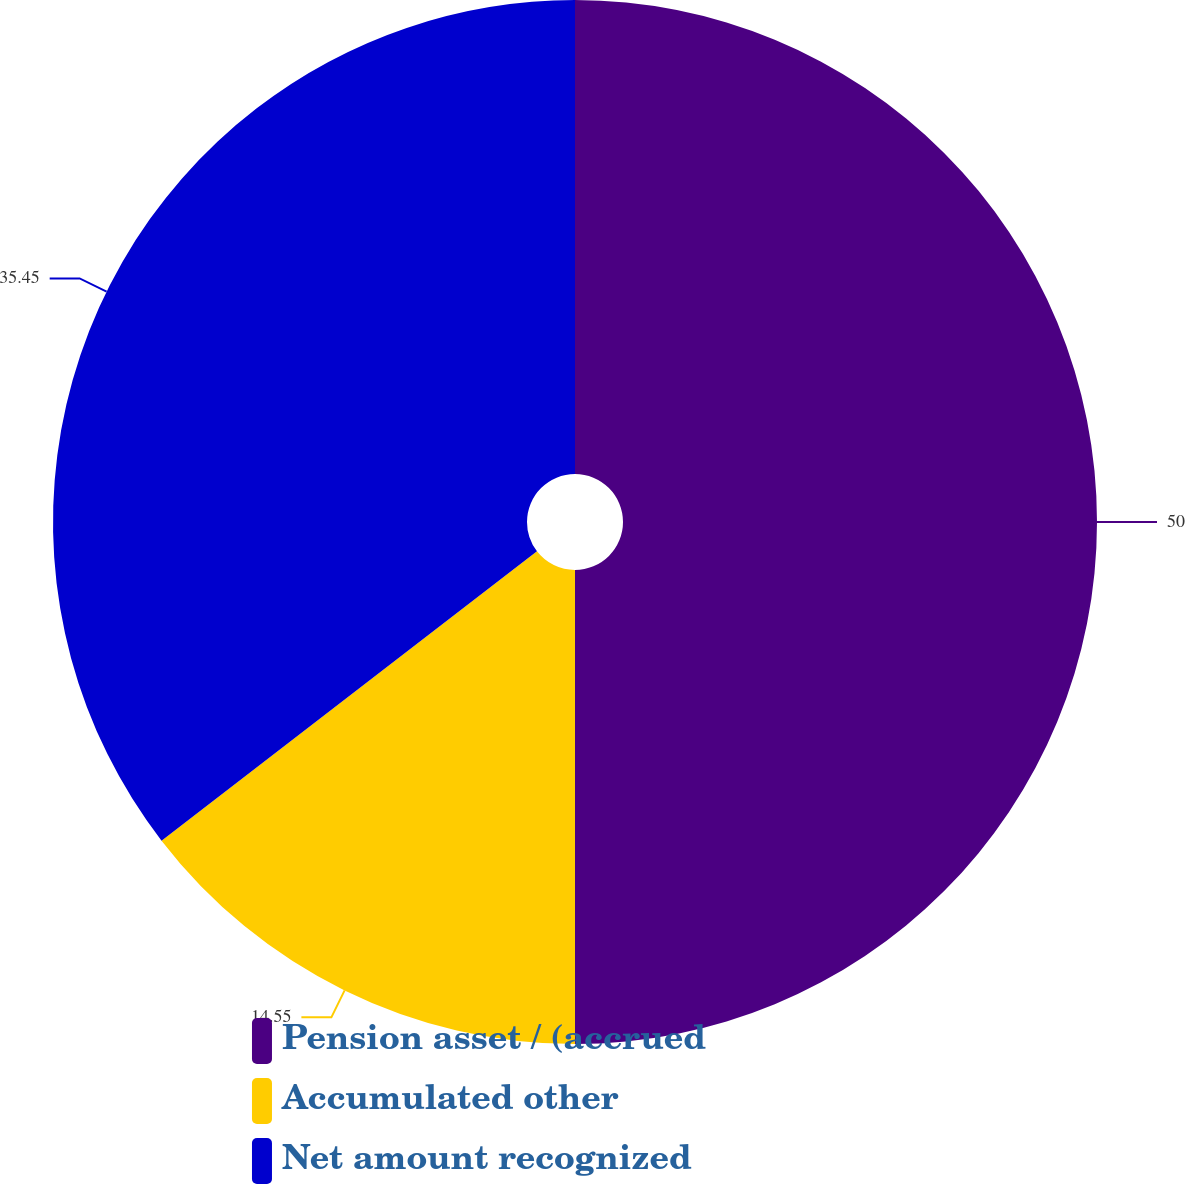Convert chart to OTSL. <chart><loc_0><loc_0><loc_500><loc_500><pie_chart><fcel>Pension asset / (accrued<fcel>Accumulated other<fcel>Net amount recognized<nl><fcel>50.0%<fcel>14.55%<fcel>35.45%<nl></chart> 